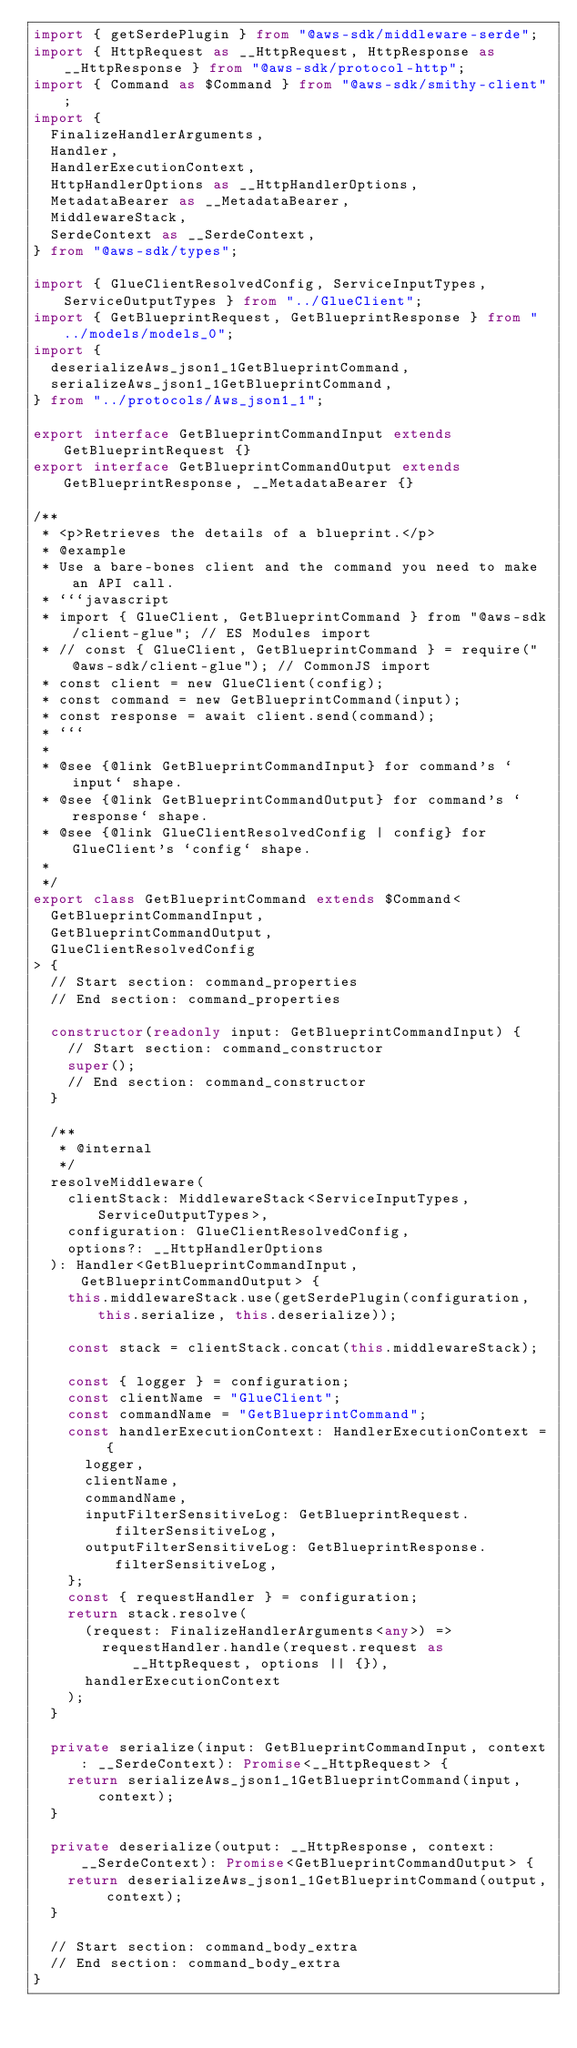<code> <loc_0><loc_0><loc_500><loc_500><_TypeScript_>import { getSerdePlugin } from "@aws-sdk/middleware-serde";
import { HttpRequest as __HttpRequest, HttpResponse as __HttpResponse } from "@aws-sdk/protocol-http";
import { Command as $Command } from "@aws-sdk/smithy-client";
import {
  FinalizeHandlerArguments,
  Handler,
  HandlerExecutionContext,
  HttpHandlerOptions as __HttpHandlerOptions,
  MetadataBearer as __MetadataBearer,
  MiddlewareStack,
  SerdeContext as __SerdeContext,
} from "@aws-sdk/types";

import { GlueClientResolvedConfig, ServiceInputTypes, ServiceOutputTypes } from "../GlueClient";
import { GetBlueprintRequest, GetBlueprintResponse } from "../models/models_0";
import {
  deserializeAws_json1_1GetBlueprintCommand,
  serializeAws_json1_1GetBlueprintCommand,
} from "../protocols/Aws_json1_1";

export interface GetBlueprintCommandInput extends GetBlueprintRequest {}
export interface GetBlueprintCommandOutput extends GetBlueprintResponse, __MetadataBearer {}

/**
 * <p>Retrieves the details of a blueprint.</p>
 * @example
 * Use a bare-bones client and the command you need to make an API call.
 * ```javascript
 * import { GlueClient, GetBlueprintCommand } from "@aws-sdk/client-glue"; // ES Modules import
 * // const { GlueClient, GetBlueprintCommand } = require("@aws-sdk/client-glue"); // CommonJS import
 * const client = new GlueClient(config);
 * const command = new GetBlueprintCommand(input);
 * const response = await client.send(command);
 * ```
 *
 * @see {@link GetBlueprintCommandInput} for command's `input` shape.
 * @see {@link GetBlueprintCommandOutput} for command's `response` shape.
 * @see {@link GlueClientResolvedConfig | config} for GlueClient's `config` shape.
 *
 */
export class GetBlueprintCommand extends $Command<
  GetBlueprintCommandInput,
  GetBlueprintCommandOutput,
  GlueClientResolvedConfig
> {
  // Start section: command_properties
  // End section: command_properties

  constructor(readonly input: GetBlueprintCommandInput) {
    // Start section: command_constructor
    super();
    // End section: command_constructor
  }

  /**
   * @internal
   */
  resolveMiddleware(
    clientStack: MiddlewareStack<ServiceInputTypes, ServiceOutputTypes>,
    configuration: GlueClientResolvedConfig,
    options?: __HttpHandlerOptions
  ): Handler<GetBlueprintCommandInput, GetBlueprintCommandOutput> {
    this.middlewareStack.use(getSerdePlugin(configuration, this.serialize, this.deserialize));

    const stack = clientStack.concat(this.middlewareStack);

    const { logger } = configuration;
    const clientName = "GlueClient";
    const commandName = "GetBlueprintCommand";
    const handlerExecutionContext: HandlerExecutionContext = {
      logger,
      clientName,
      commandName,
      inputFilterSensitiveLog: GetBlueprintRequest.filterSensitiveLog,
      outputFilterSensitiveLog: GetBlueprintResponse.filterSensitiveLog,
    };
    const { requestHandler } = configuration;
    return stack.resolve(
      (request: FinalizeHandlerArguments<any>) =>
        requestHandler.handle(request.request as __HttpRequest, options || {}),
      handlerExecutionContext
    );
  }

  private serialize(input: GetBlueprintCommandInput, context: __SerdeContext): Promise<__HttpRequest> {
    return serializeAws_json1_1GetBlueprintCommand(input, context);
  }

  private deserialize(output: __HttpResponse, context: __SerdeContext): Promise<GetBlueprintCommandOutput> {
    return deserializeAws_json1_1GetBlueprintCommand(output, context);
  }

  // Start section: command_body_extra
  // End section: command_body_extra
}
</code> 